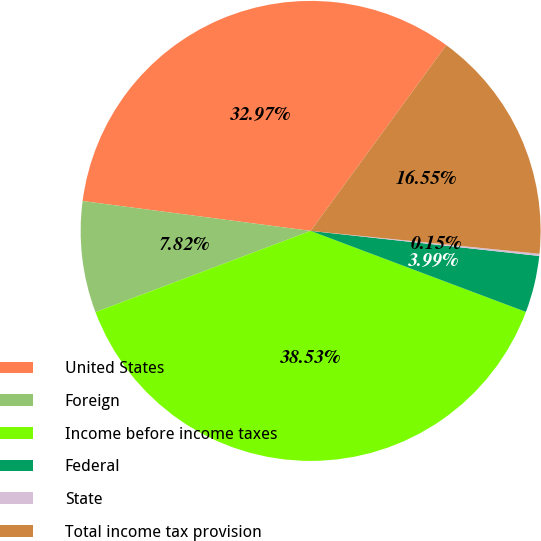<chart> <loc_0><loc_0><loc_500><loc_500><pie_chart><fcel>United States<fcel>Foreign<fcel>Income before income taxes<fcel>Federal<fcel>State<fcel>Total income tax provision<nl><fcel>32.97%<fcel>7.82%<fcel>38.53%<fcel>3.99%<fcel>0.15%<fcel>16.55%<nl></chart> 